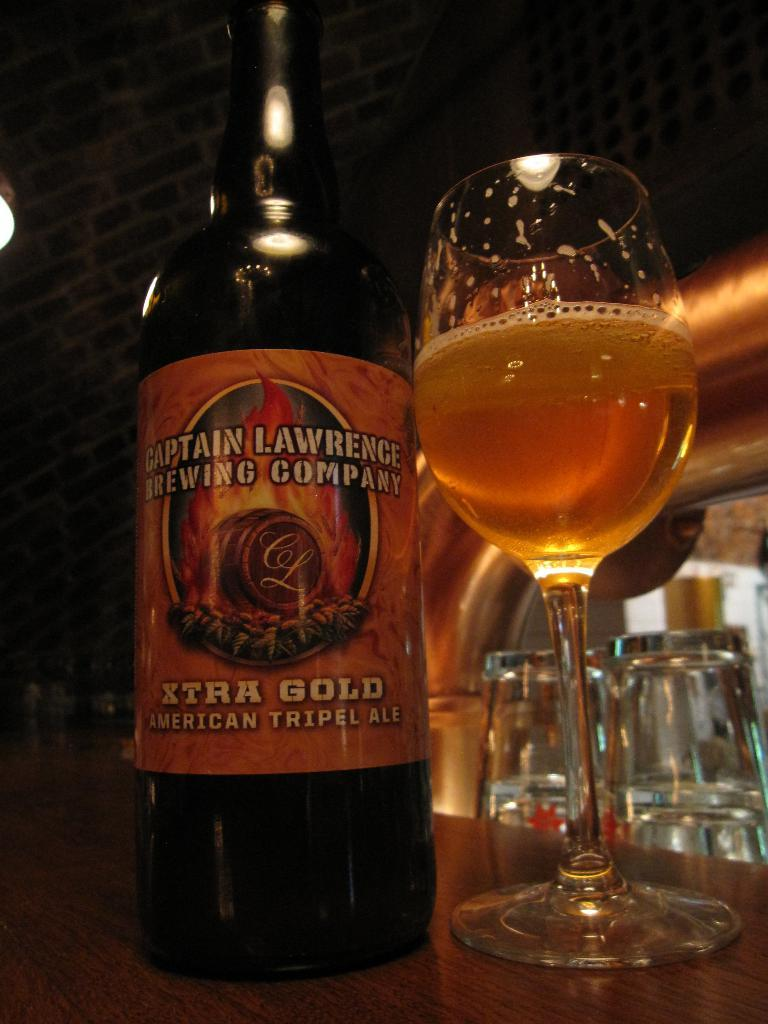<image>
Render a clear and concise summary of the photo. a bottle of alcohol labeled: Captain Lawrence brewing company 